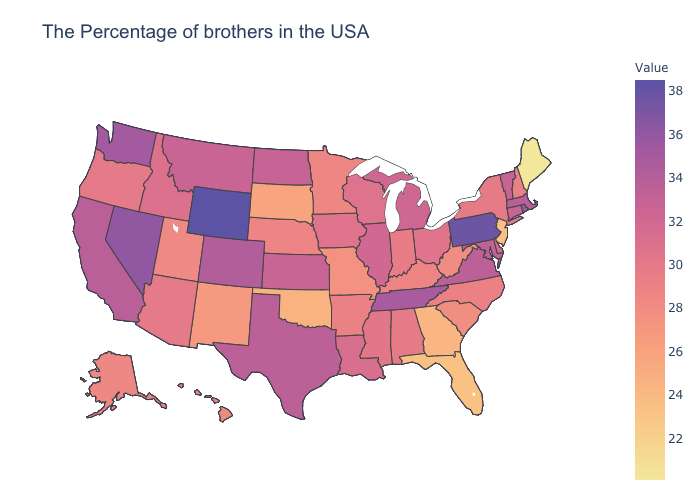Does Arkansas have the highest value in the USA?
Write a very short answer. No. Among the states that border Kentucky , does Tennessee have the lowest value?
Give a very brief answer. No. Which states have the lowest value in the USA?
Be succinct. Maine. 